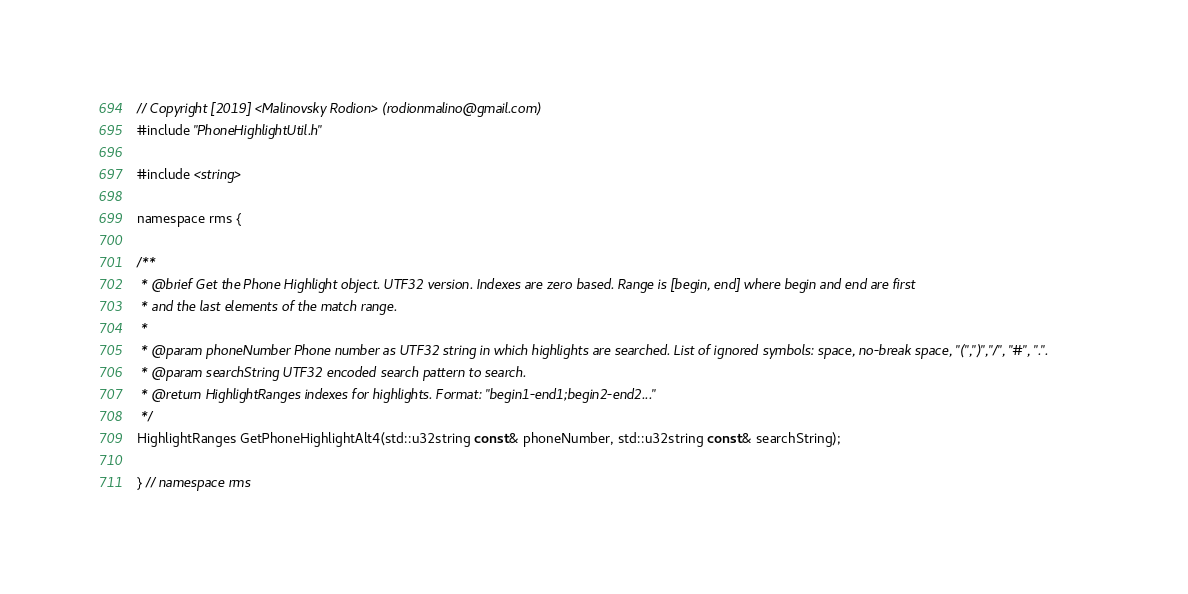<code> <loc_0><loc_0><loc_500><loc_500><_C_>// Copyright [2019] <Malinovsky Rodion> (rodionmalino@gmail.com)
#include "PhoneHighlightUtil.h"

#include <string>

namespace rms {

/**
 * @brief Get the Phone Highlight object. UTF32 version. Indexes are zero based. Range is [begin, end] where begin and end are first
 * and the last elements of the match range.
 *
 * @param phoneNumber Phone number as UTF32 string in which highlights are searched. List of ignored symbols: space, no-break space, "(",")","/", "#", ".". 
 * @param searchString UTF32 encoded search pattern to search.
 * @return HighlightRanges indexes for highlights. Format: "begin1-end1;begin2-end2..."
 */
HighlightRanges GetPhoneHighlightAlt4(std::u32string const& phoneNumber, std::u32string const& searchString);

} // namespace rms
</code> 